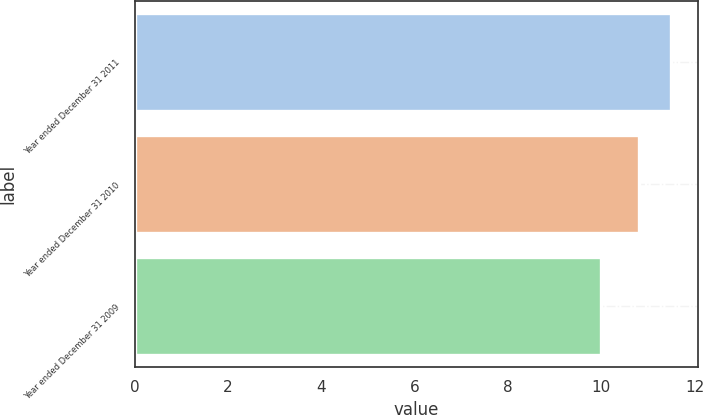Convert chart to OTSL. <chart><loc_0><loc_0><loc_500><loc_500><bar_chart><fcel>Year ended December 31 2011<fcel>Year ended December 31 2010<fcel>Year ended December 31 2009<nl><fcel>11.5<fcel>10.8<fcel>10<nl></chart> 